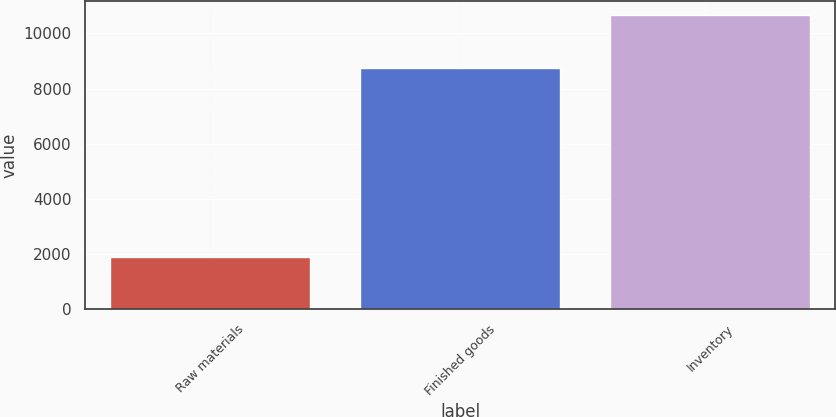Convert chart. <chart><loc_0><loc_0><loc_500><loc_500><bar_chart><fcel>Raw materials<fcel>Finished goods<fcel>Inventory<nl><fcel>1904<fcel>8745<fcel>10649<nl></chart> 